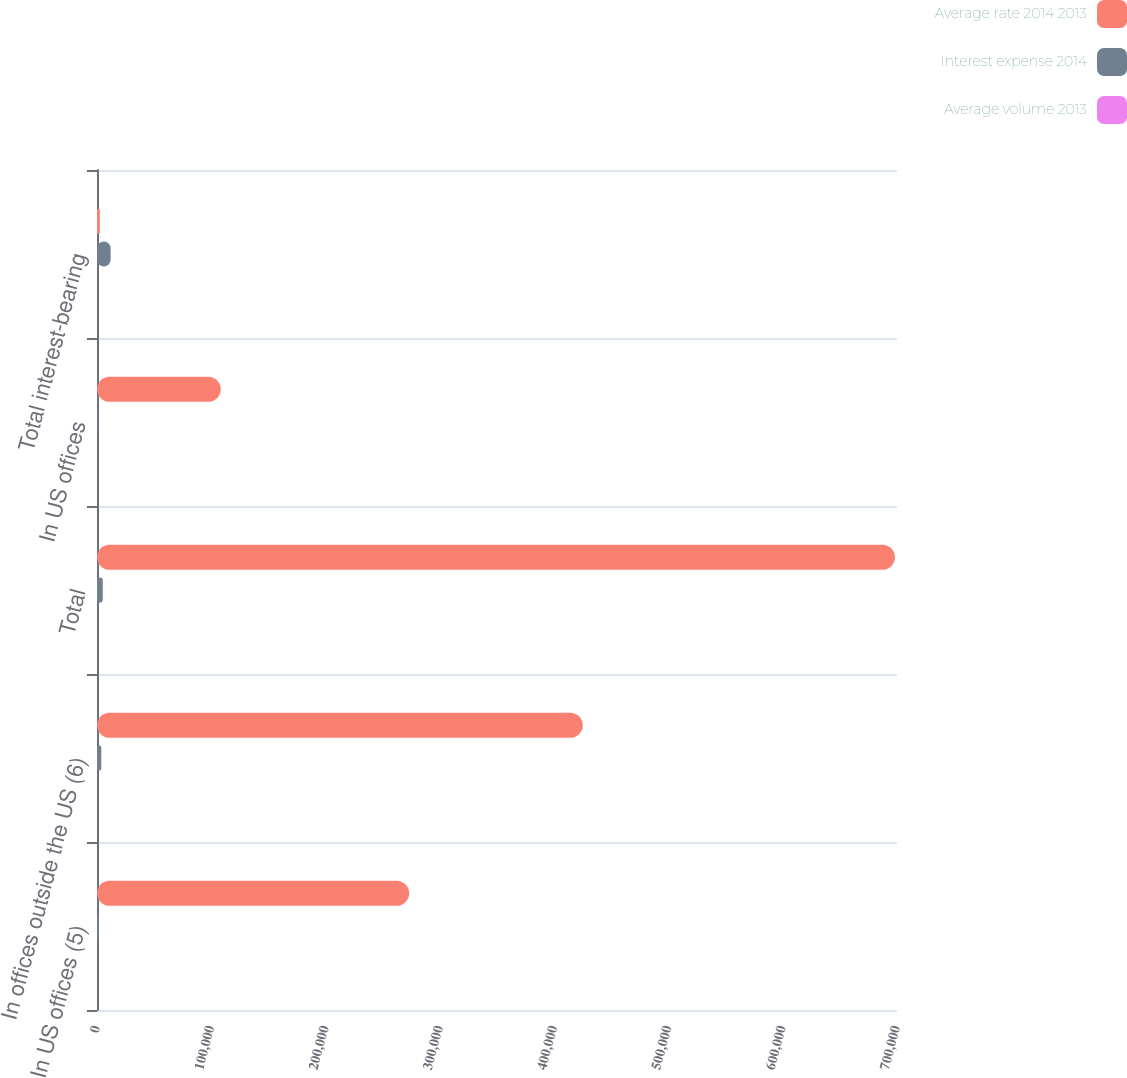Convert chart. <chart><loc_0><loc_0><loc_500><loc_500><stacked_bar_chart><ecel><fcel>In US offices (5)<fcel>In offices outside the US (6)<fcel>Total<fcel>In US offices<fcel>Total interest-bearing<nl><fcel>Average rate 2014 2013<fcel>273122<fcel>425053<fcel>698175<fcel>108286<fcel>2526<nl><fcel>Interest expense 2014<fcel>1291<fcel>3761<fcel>5052<fcel>721<fcel>11921<nl><fcel>Average volume 2013<fcel>0.47<fcel>0.88<fcel>0.72<fcel>0.67<fcel>0.95<nl></chart> 